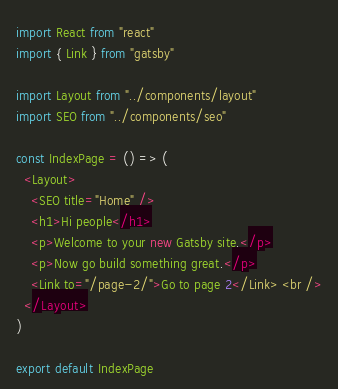Convert code to text. <code><loc_0><loc_0><loc_500><loc_500><_JavaScript_>import React from "react"
import { Link } from "gatsby"

import Layout from "../components/layout"
import SEO from "../components/seo"

const IndexPage = () => (
  <Layout>
    <SEO title="Home" />
    <h1>Hi people</h1>
    <p>Welcome to your new Gatsby site.</p>
    <p>Now go build something great.</p>
    <Link to="/page-2/">Go to page 2</Link> <br />
  </Layout>
)

export default IndexPage
</code> 